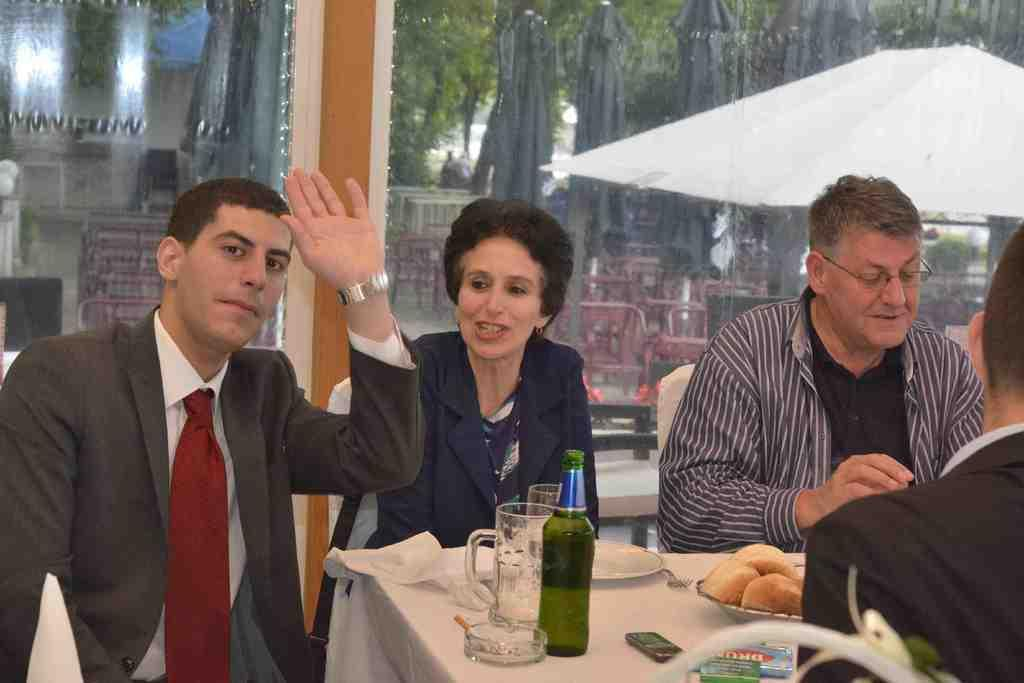What are the people in the image doing? The people in the image are sitting around tables. What can be seen on the tables? There are things placed on the tables. What is the purpose of the glass mirror in the image? The glass mirror allows trees to be visible through it. How many dogs are lying on the sheet in the image? There are no dogs or sheets present in the image. 